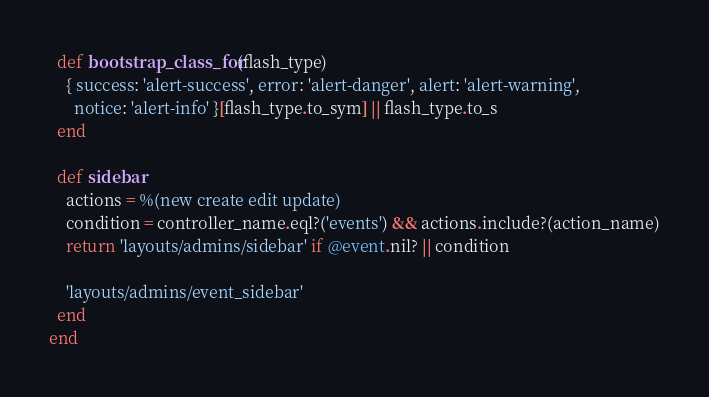Convert code to text. <code><loc_0><loc_0><loc_500><loc_500><_Ruby_>  def bootstrap_class_for(flash_type)
    { success: 'alert-success', error: 'alert-danger', alert: 'alert-warning',
      notice: 'alert-info' }[flash_type.to_sym] || flash_type.to_s
  end

  def sidebar
    actions = %(new create edit update)
    condition = controller_name.eql?('events') && actions.include?(action_name)
    return 'layouts/admins/sidebar' if @event.nil? || condition

    'layouts/admins/event_sidebar'
  end
end
</code> 